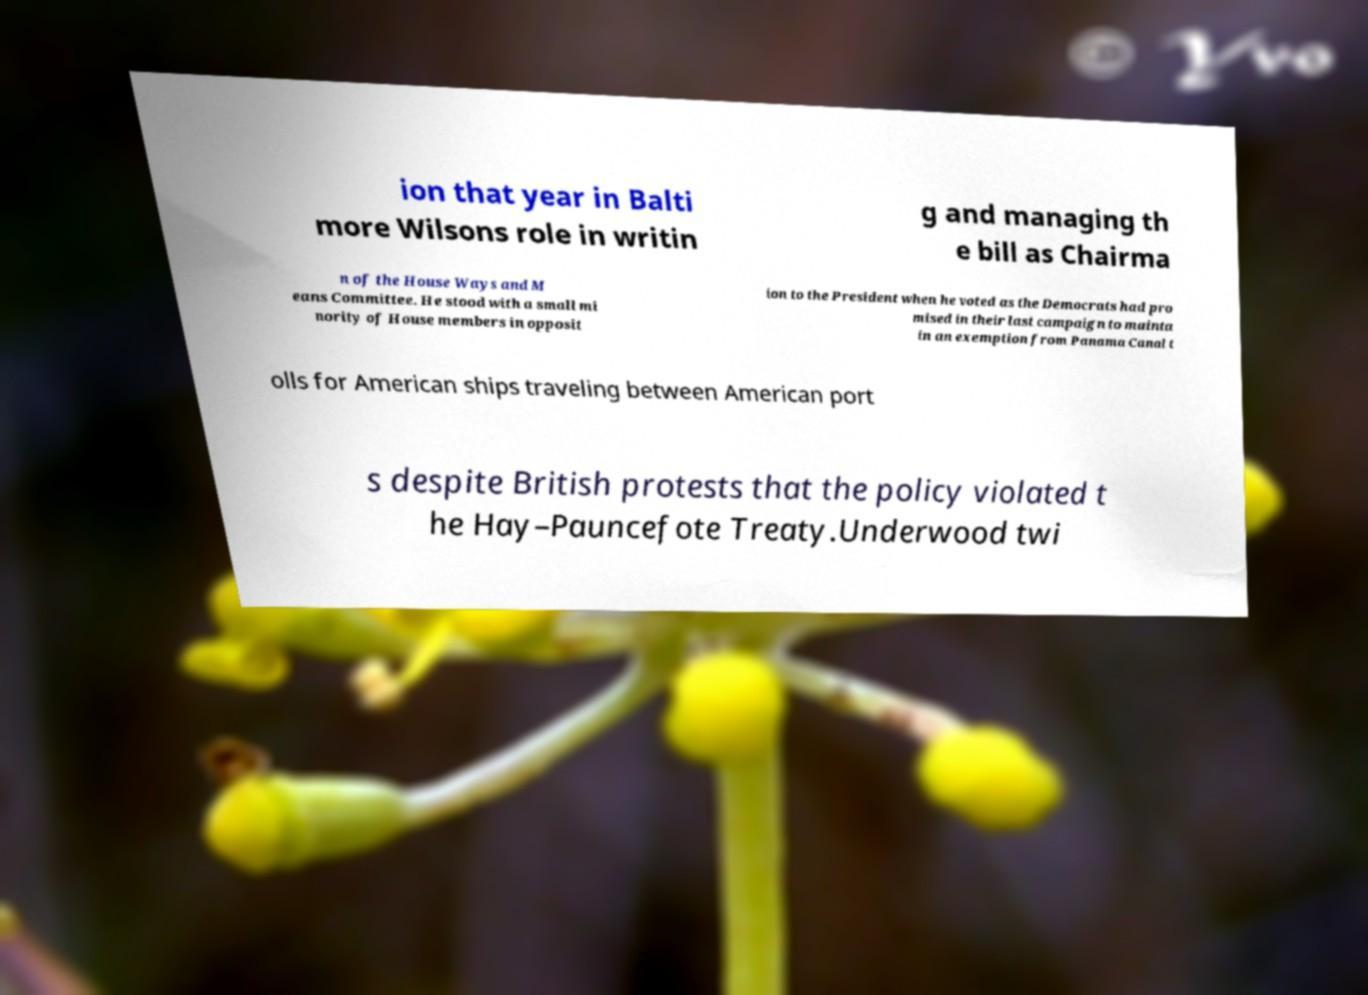Please read and relay the text visible in this image. What does it say? ion that year in Balti more Wilsons role in writin g and managing th e bill as Chairma n of the House Ways and M eans Committee. He stood with a small mi nority of House members in opposit ion to the President when he voted as the Democrats had pro mised in their last campaign to mainta in an exemption from Panama Canal t olls for American ships traveling between American port s despite British protests that the policy violated t he Hay–Pauncefote Treaty.Underwood twi 